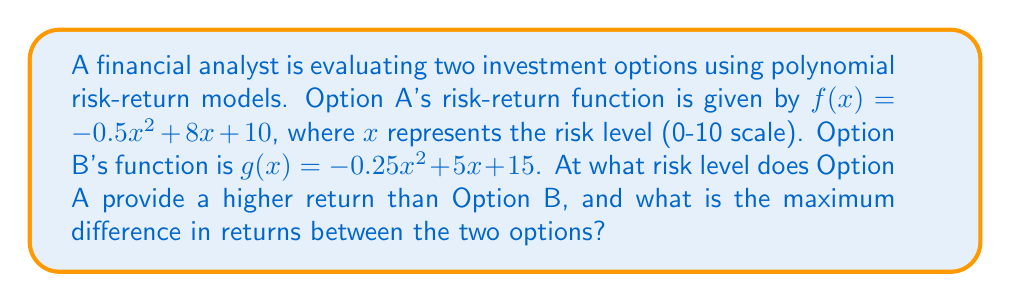What is the answer to this math problem? 1) To find where Option A provides a higher return, we need to solve the inequality:
   $f(x) > g(x)$
   $-0.5x^2 + 8x + 10 > -0.25x^2 + 5x + 15$

2) Rearranging the terms:
   $-0.25x^2 + 3x - 5 > 0$

3) Solving this quadratic inequality:
   $a = -0.25$, $b = 3$, $c = -5$
   
   Discriminant: $b^2 - 4ac = 3^2 - 4(-0.25)(-5) = 9 - 5 = 4$

   Roots: $x = \frac{-b \pm \sqrt{b^2 - 4ac}}{2a}$
   $x_1 = \frac{-3 + 2}{-0.5} = 2$
   $x_2 = \frac{-3 - 2}{-0.5} = 10$

4) The inequality is true for $2 < x < 10$. Since risk is on a 0-10 scale, Option A provides higher returns when $2 < x \leq 10$.

5) To find the maximum difference, we need to maximize $f(x) - g(x)$:
   $h(x) = f(x) - g(x) = (-0.5x^2 + 8x + 10) - (-0.25x^2 + 5x + 15)$
   $h(x) = -0.25x^2 + 3x - 5$

6) The maximum occurs at the vertex of this parabola:
   $x = -\frac{b}{2a} = -\frac{3}{2(-0.25)} = 6$

7) The maximum difference is:
   $h(6) = -0.25(6)^2 + 3(6) - 5 = -9 + 18 - 5 = 4$
Answer: Option A provides higher returns when $2 < x \leq 10$; maximum difference is 4 at $x = 6$ 